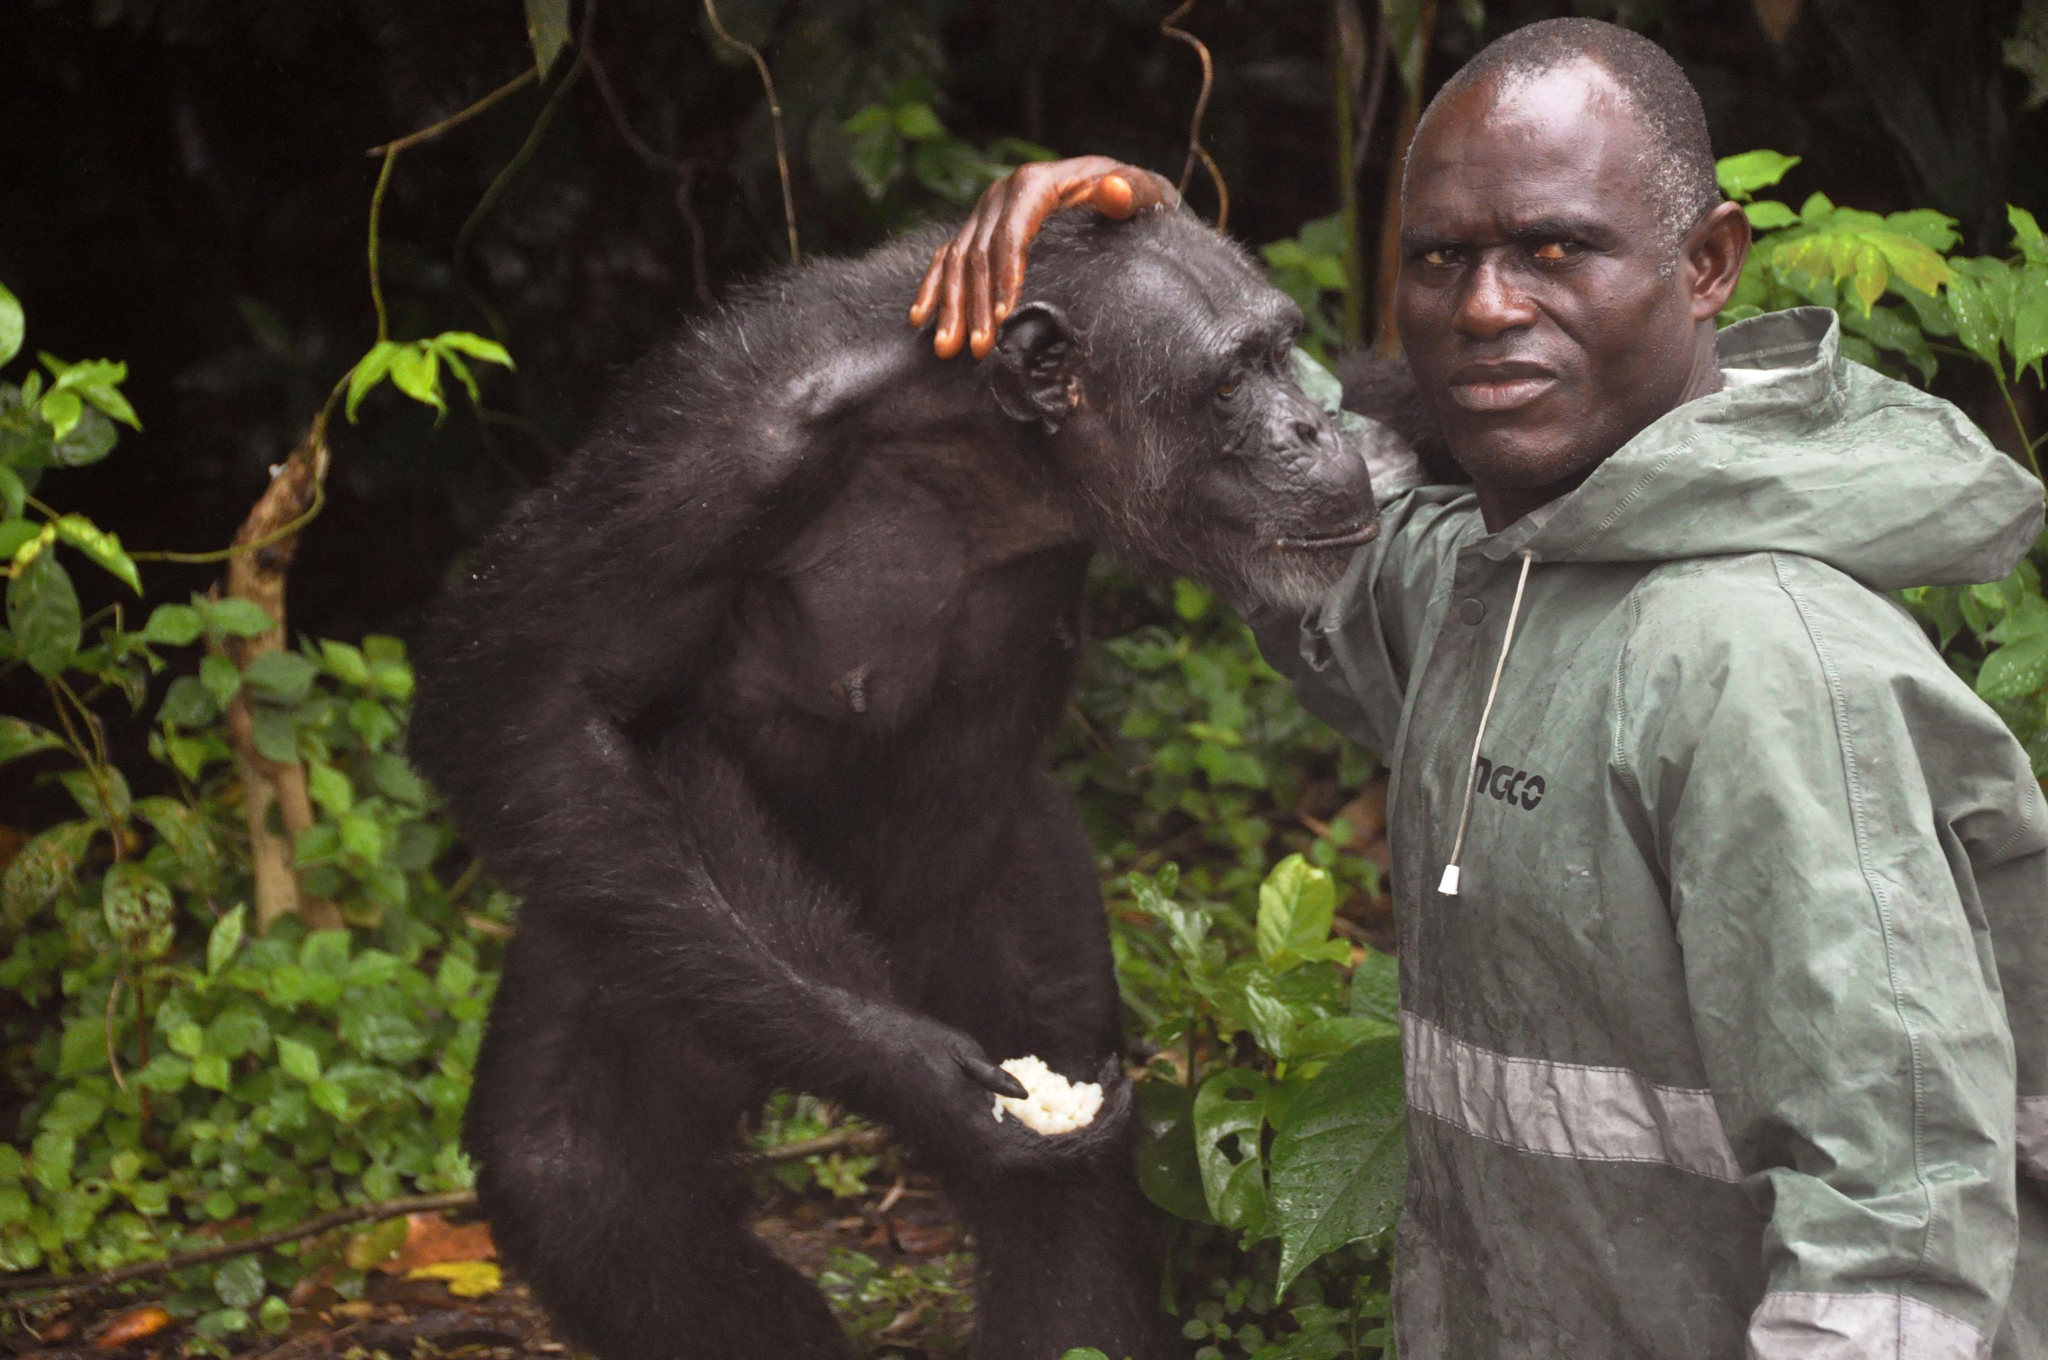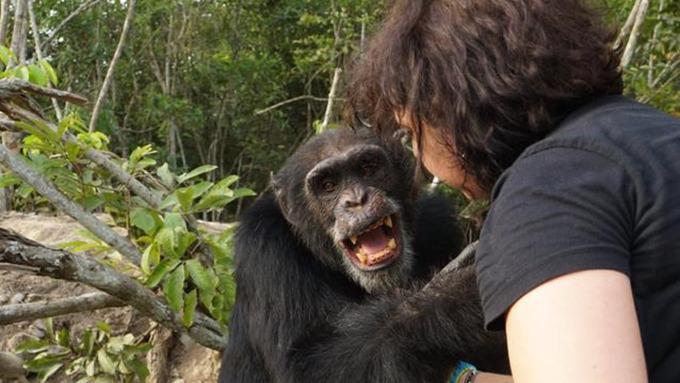The first image is the image on the left, the second image is the image on the right. Evaluate the accuracy of this statement regarding the images: "Each image shows one person interacting with at least one chimp, and one image shows a black man with his hand on a chimp's head.". Is it true? Answer yes or no. Yes. The first image is the image on the left, the second image is the image on the right. Examine the images to the left and right. Is the description "There is at least four chimpanzees in the right image." accurate? Answer yes or no. No. 